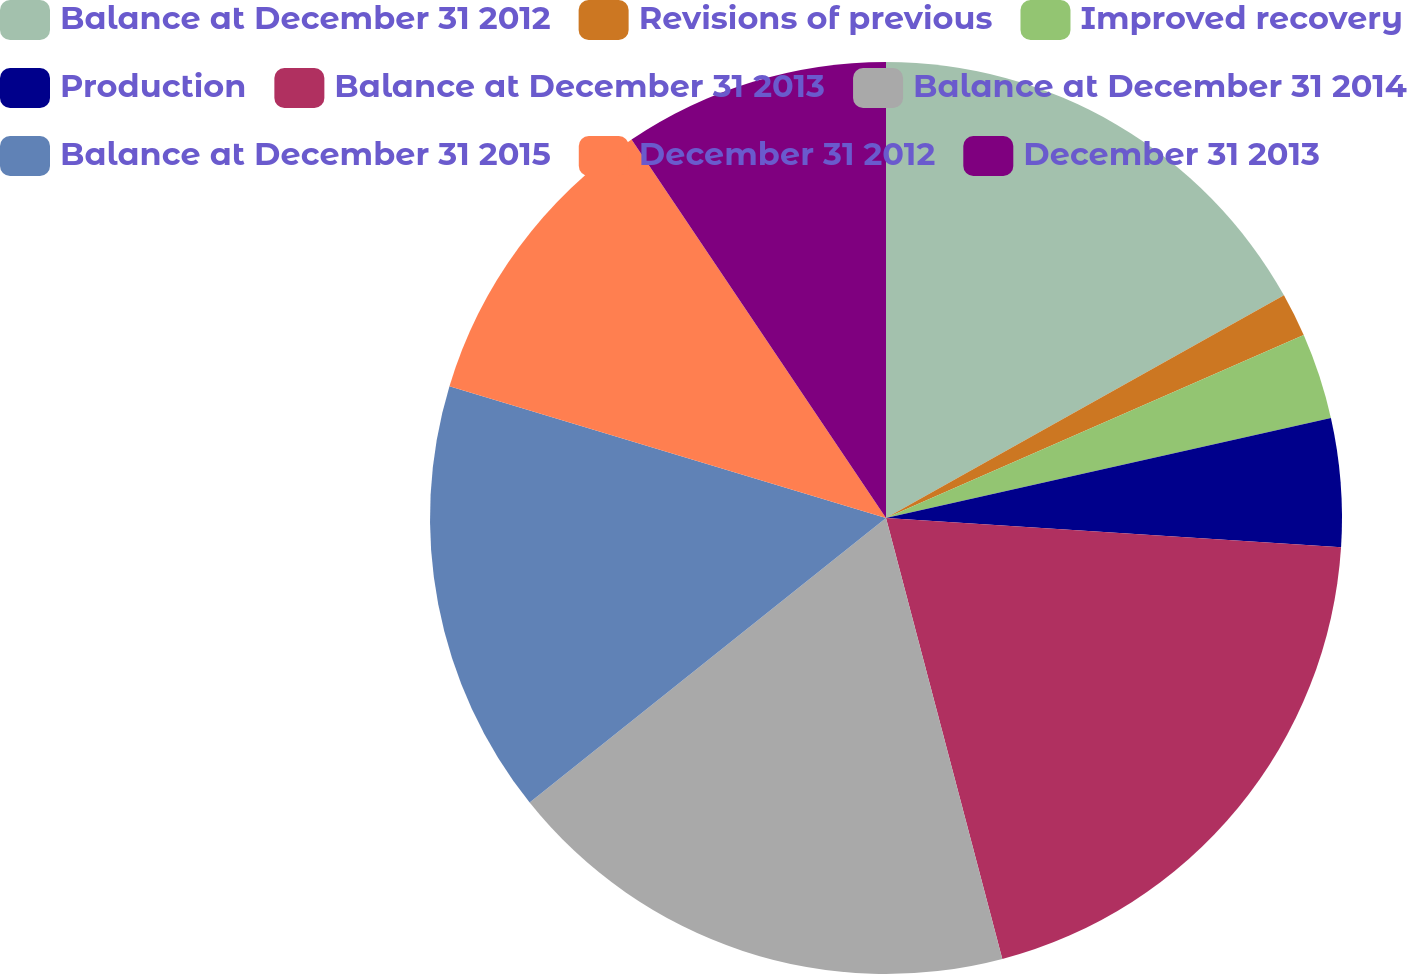Convert chart to OTSL. <chart><loc_0><loc_0><loc_500><loc_500><pie_chart><fcel>Balance at December 31 2012<fcel>Revisions of previous<fcel>Improved recovery<fcel>Production<fcel>Balance at December 31 2013<fcel>Balance at December 31 2014<fcel>Balance at December 31 2015<fcel>December 31 2012<fcel>December 31 2013<nl><fcel>16.88%<fcel>1.55%<fcel>3.05%<fcel>4.54%<fcel>19.87%<fcel>18.38%<fcel>15.39%<fcel>10.91%<fcel>9.42%<nl></chart> 